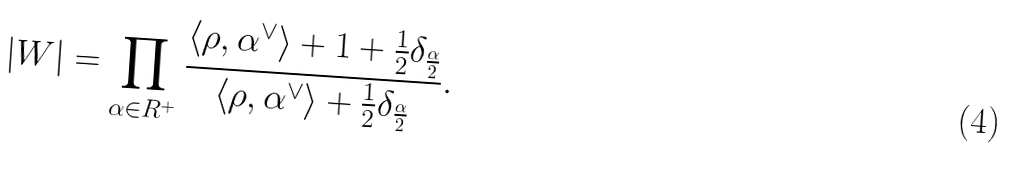<formula> <loc_0><loc_0><loc_500><loc_500>| W | = \prod _ { \alpha \in R ^ { + } } \frac { \langle \rho , \alpha ^ { \vee } \rangle + 1 + \frac { 1 } { 2 } \delta _ { \frac { \alpha } { 2 } } } { \langle \rho , \alpha ^ { \vee } \rangle + \frac { 1 } { 2 } \delta _ { \frac { \alpha } { 2 } } } .</formula> 